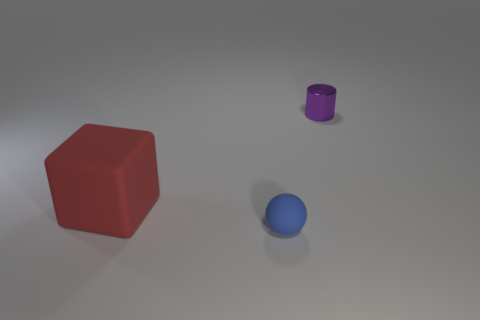What shape is the matte object that is the same size as the cylinder?
Your answer should be very brief. Sphere. Is the number of tiny purple shiny cylinders behind the purple cylinder the same as the number of big rubber cylinders?
Your response must be concise. Yes. The thing that is left of the tiny object that is in front of the rubber thing behind the blue ball is made of what material?
Offer a terse response. Rubber. There is a small blue object that is the same material as the large block; what is its shape?
Your response must be concise. Sphere. Is there anything else that is the same color as the small shiny object?
Offer a terse response. No. There is a thing that is on the left side of the tiny thing in front of the purple object; what number of large red rubber cubes are on the right side of it?
Your answer should be very brief. 0. What number of green objects are cylinders or big cubes?
Offer a very short reply. 0. Does the purple metal thing have the same size as the rubber thing that is to the right of the big red thing?
Offer a very short reply. Yes. How many other things are there of the same size as the blue thing?
Keep it short and to the point. 1. What shape is the object behind the matte thing that is to the left of the rubber thing to the right of the red thing?
Your answer should be very brief. Cylinder. 